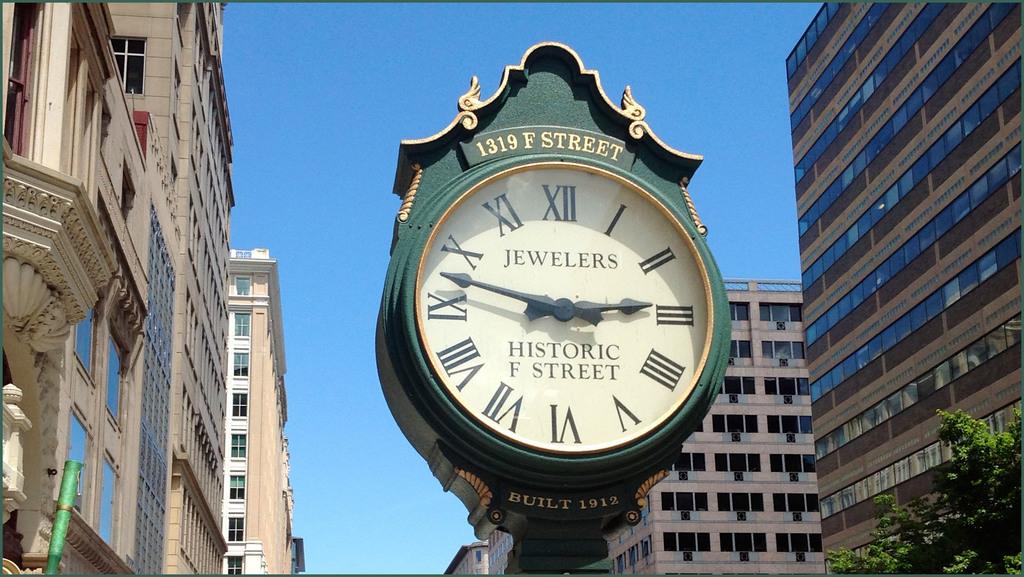What is the address on the clock?
Make the answer very short. 1319 f street. What is the first word written on the clock?
Your answer should be very brief. Jewelers. 